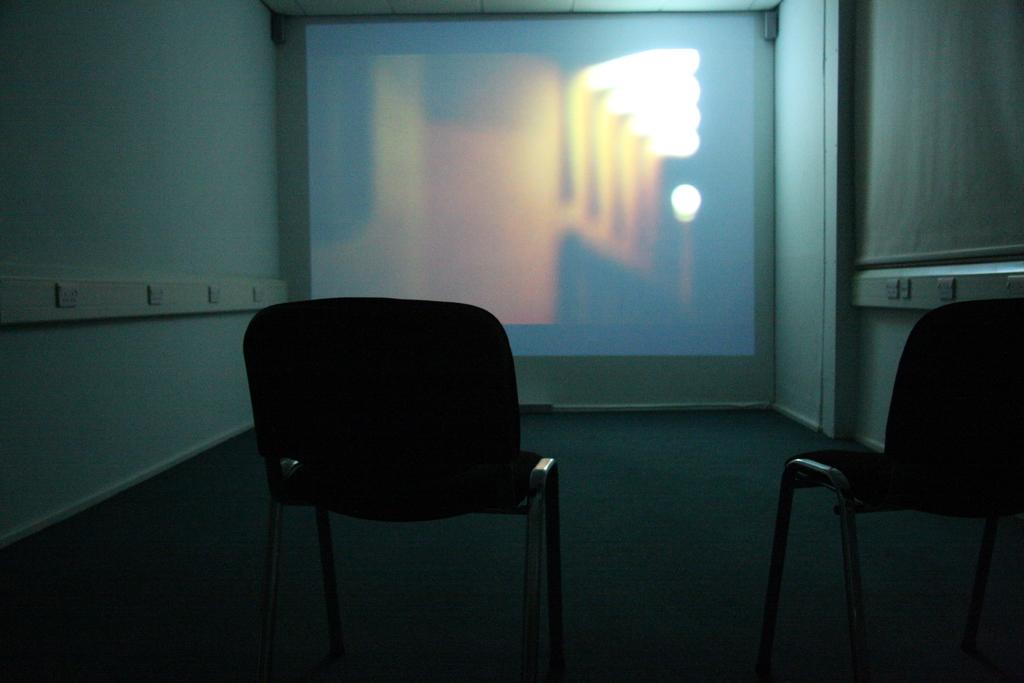What type of furniture is located in the front of the image? There are two chairs in the front of the image. What can be seen on the wall in the back of the image? There is a screen on the wall in the back of the image. What surrounds the screen on the wall? There are walls on either side of the screen. How does the sheet fall from the ceiling in the image? There is no sheet present in the image, so it cannot fall from the ceiling. 